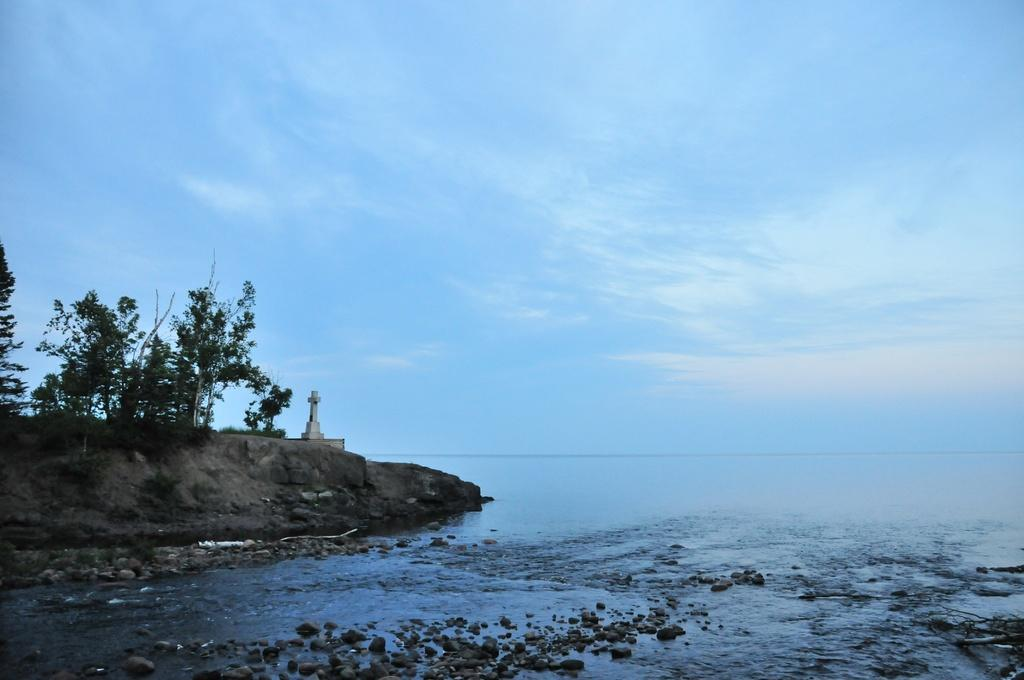What is located at the bottom of the image? There are stones and water at the bottom of the image. What can be seen on the left side of the image? There are trees on the left side of the image. What symbol is present on the ground in the image? There is a cross symbol on the ground. What is visible in the background of the image? There is water and clouds visible in the background of the image. Can you tell me how many chess pieces are on the ground in the image? There are no chess pieces present in the image. What type of food is being cooked in the image? There is no cooking or food preparation activity depicted in the image. 